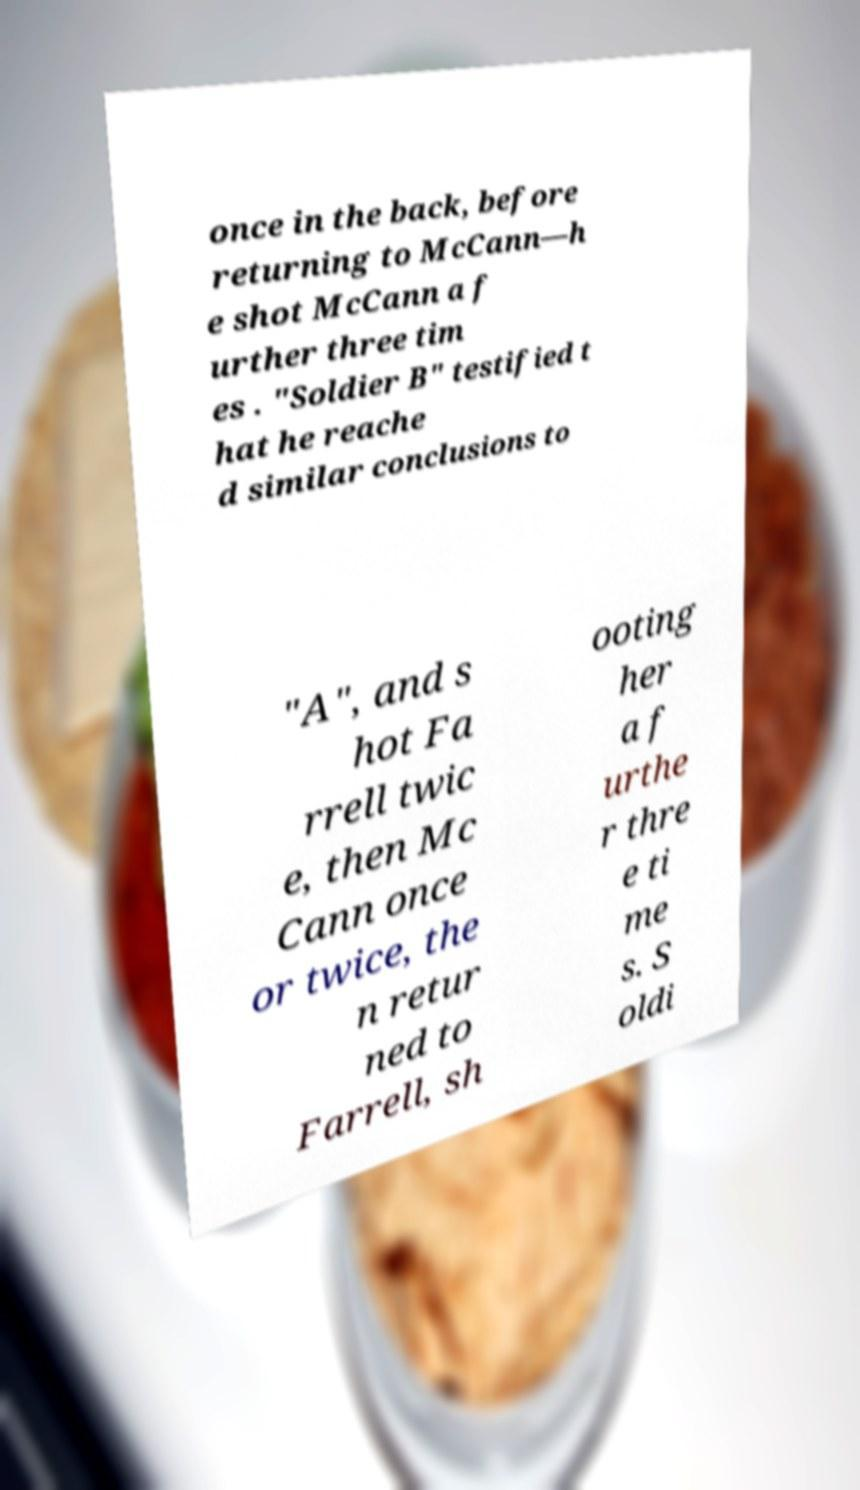I need the written content from this picture converted into text. Can you do that? once in the back, before returning to McCann—h e shot McCann a f urther three tim es . "Soldier B" testified t hat he reache d similar conclusions to "A", and s hot Fa rrell twic e, then Mc Cann once or twice, the n retur ned to Farrell, sh ooting her a f urthe r thre e ti me s. S oldi 